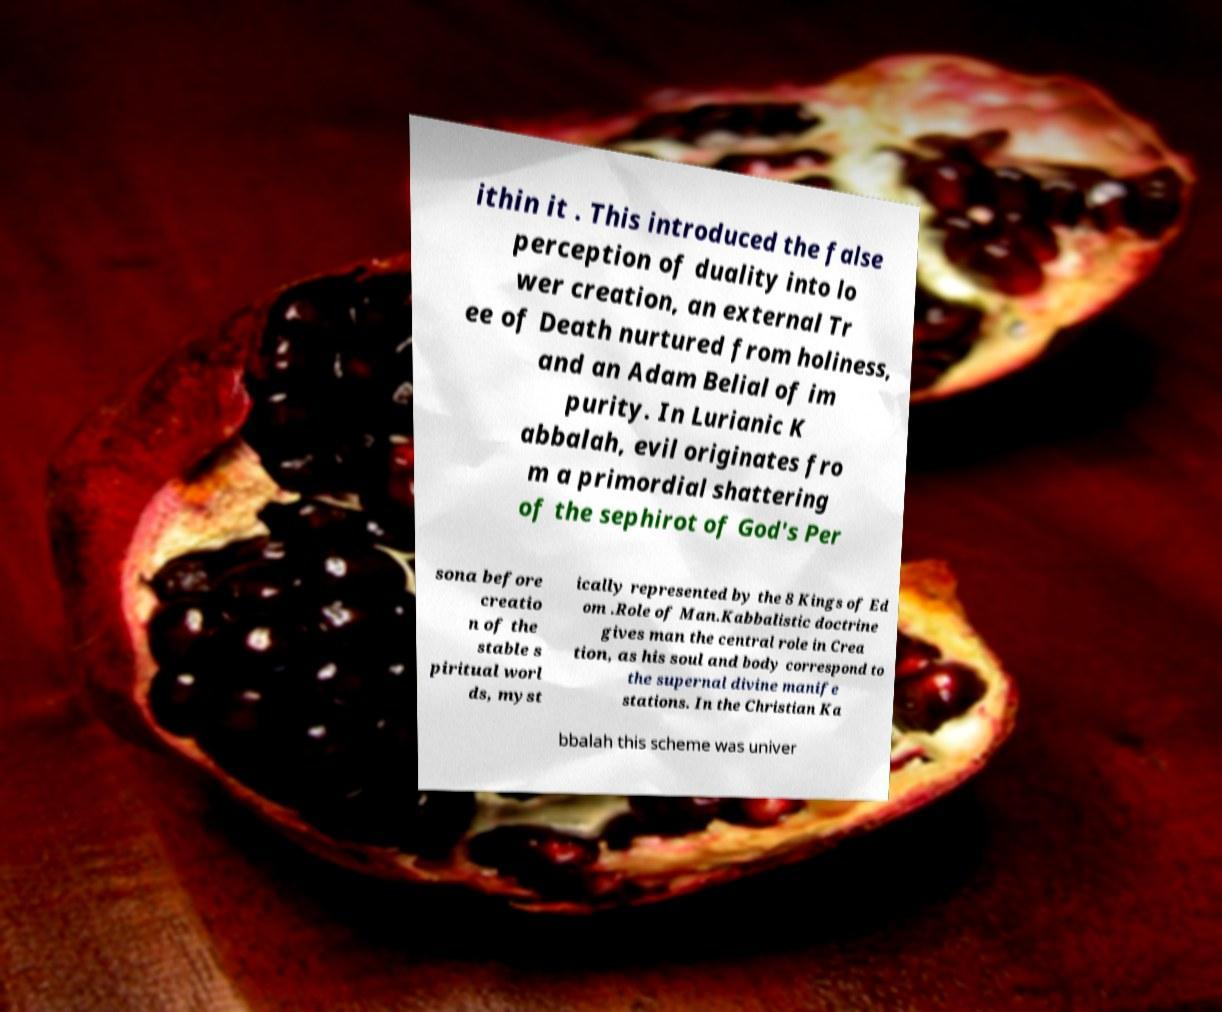Please identify and transcribe the text found in this image. ithin it . This introduced the false perception of duality into lo wer creation, an external Tr ee of Death nurtured from holiness, and an Adam Belial of im purity. In Lurianic K abbalah, evil originates fro m a primordial shattering of the sephirot of God's Per sona before creatio n of the stable s piritual worl ds, myst ically represented by the 8 Kings of Ed om .Role of Man.Kabbalistic doctrine gives man the central role in Crea tion, as his soul and body correspond to the supernal divine manife stations. In the Christian Ka bbalah this scheme was univer 